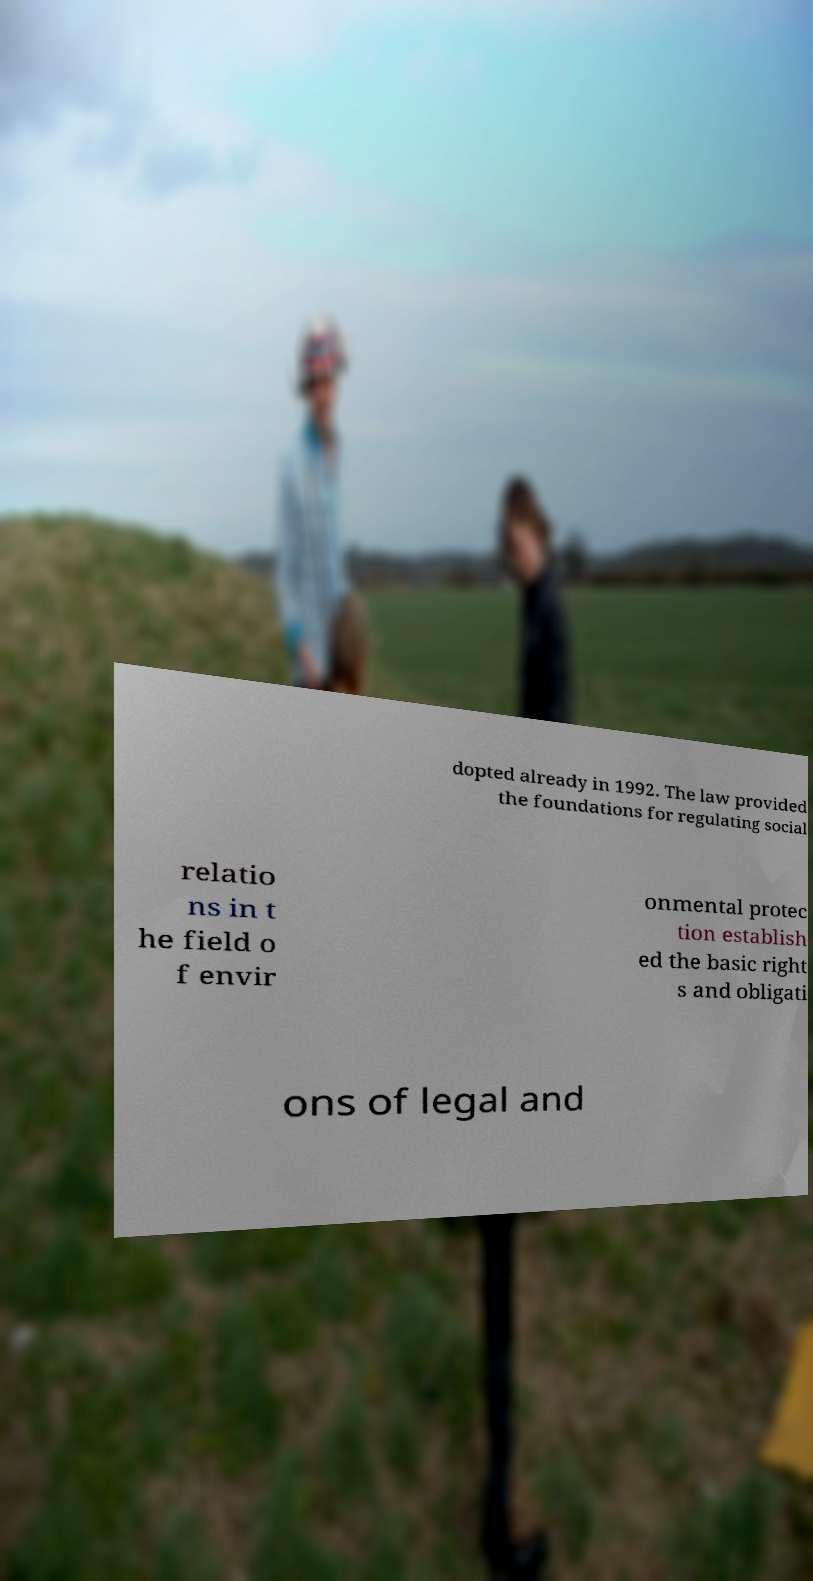Please identify and transcribe the text found in this image. dopted already in 1992. The law provided the foundations for regulating social relatio ns in t he field o f envir onmental protec tion establish ed the basic right s and obligati ons of legal and 